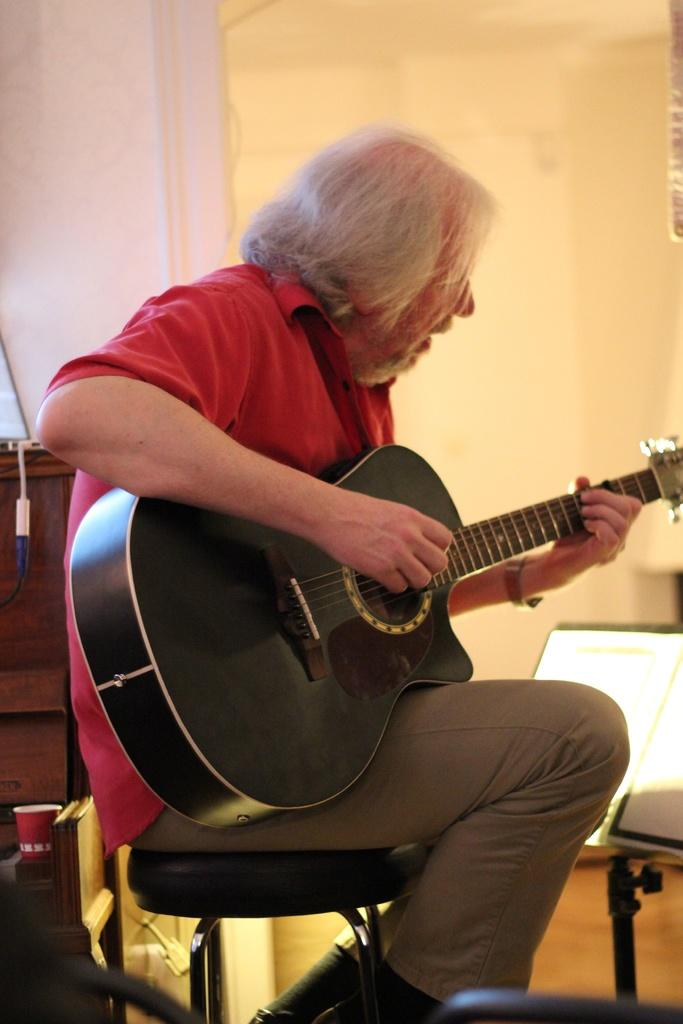What is the person in the image doing? The person is sitting on a chair and holding a guitar. What can be seen in the background of the image? There is a wall, a light, and a table in the background of the image. How many family members are visible in the image? There is no indication of family members in the image; it only shows a person sitting on a chair and holding a guitar. What type of balance does the light provide in the image? The image does not mention any specific type of balance provided by the light; it simply states that there is a light in the background. 